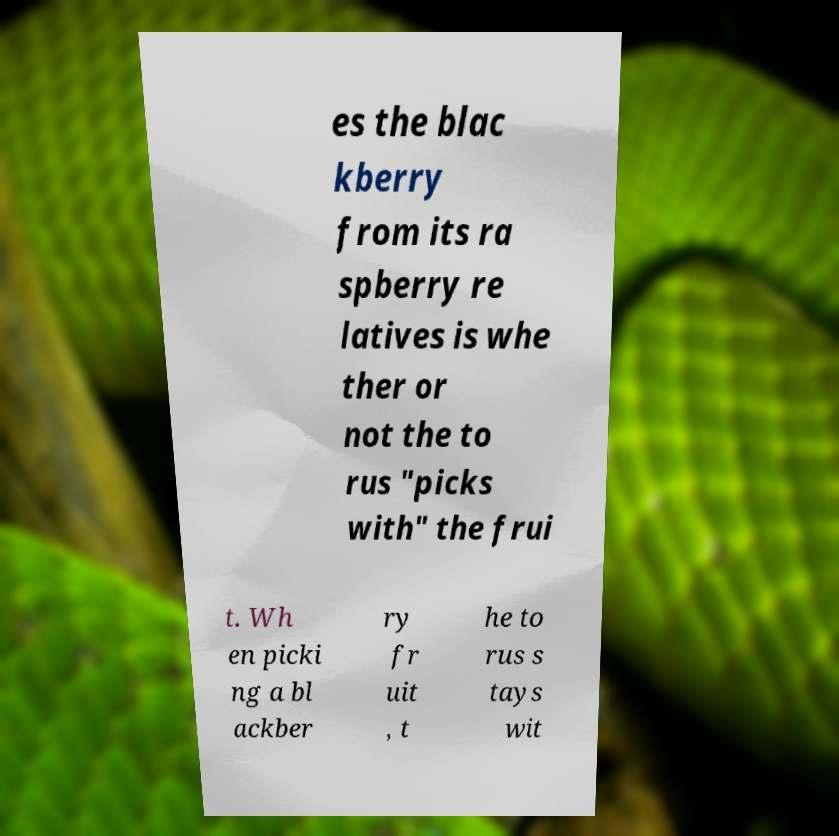What messages or text are displayed in this image? I need them in a readable, typed format. es the blac kberry from its ra spberry re latives is whe ther or not the to rus "picks with" the frui t. Wh en picki ng a bl ackber ry fr uit , t he to rus s tays wit 